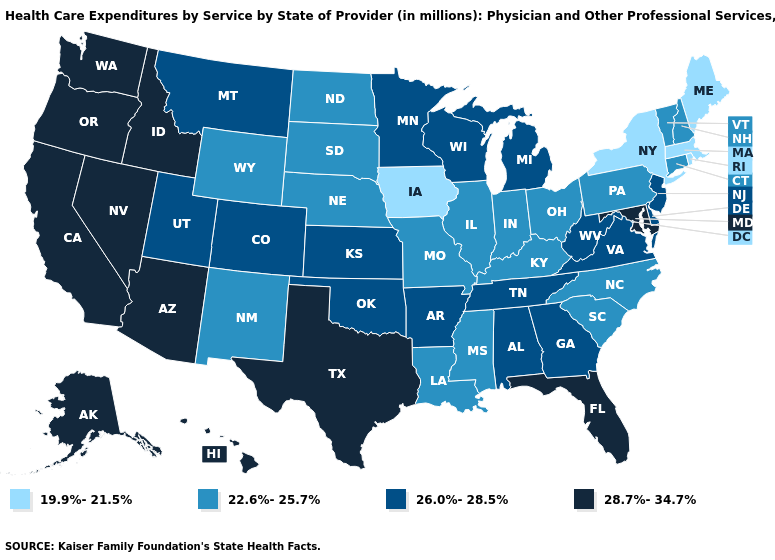Name the states that have a value in the range 22.6%-25.7%?
Answer briefly. Connecticut, Illinois, Indiana, Kentucky, Louisiana, Mississippi, Missouri, Nebraska, New Hampshire, New Mexico, North Carolina, North Dakota, Ohio, Pennsylvania, South Carolina, South Dakota, Vermont, Wyoming. Does Arizona have a higher value than Michigan?
Answer briefly. Yes. What is the value of Mississippi?
Concise answer only. 22.6%-25.7%. Name the states that have a value in the range 26.0%-28.5%?
Write a very short answer. Alabama, Arkansas, Colorado, Delaware, Georgia, Kansas, Michigan, Minnesota, Montana, New Jersey, Oklahoma, Tennessee, Utah, Virginia, West Virginia, Wisconsin. What is the value of North Carolina?
Be succinct. 22.6%-25.7%. Name the states that have a value in the range 22.6%-25.7%?
Write a very short answer. Connecticut, Illinois, Indiana, Kentucky, Louisiana, Mississippi, Missouri, Nebraska, New Hampshire, New Mexico, North Carolina, North Dakota, Ohio, Pennsylvania, South Carolina, South Dakota, Vermont, Wyoming. What is the value of Kentucky?
Be succinct. 22.6%-25.7%. Which states hav the highest value in the MidWest?
Concise answer only. Kansas, Michigan, Minnesota, Wisconsin. Among the states that border Nebraska , which have the lowest value?
Short answer required. Iowa. Does the map have missing data?
Concise answer only. No. What is the highest value in the West ?
Keep it brief. 28.7%-34.7%. Name the states that have a value in the range 22.6%-25.7%?
Write a very short answer. Connecticut, Illinois, Indiana, Kentucky, Louisiana, Mississippi, Missouri, Nebraska, New Hampshire, New Mexico, North Carolina, North Dakota, Ohio, Pennsylvania, South Carolina, South Dakota, Vermont, Wyoming. Name the states that have a value in the range 22.6%-25.7%?
Short answer required. Connecticut, Illinois, Indiana, Kentucky, Louisiana, Mississippi, Missouri, Nebraska, New Hampshire, New Mexico, North Carolina, North Dakota, Ohio, Pennsylvania, South Carolina, South Dakota, Vermont, Wyoming. What is the highest value in the Northeast ?
Write a very short answer. 26.0%-28.5%. What is the value of Illinois?
Concise answer only. 22.6%-25.7%. 